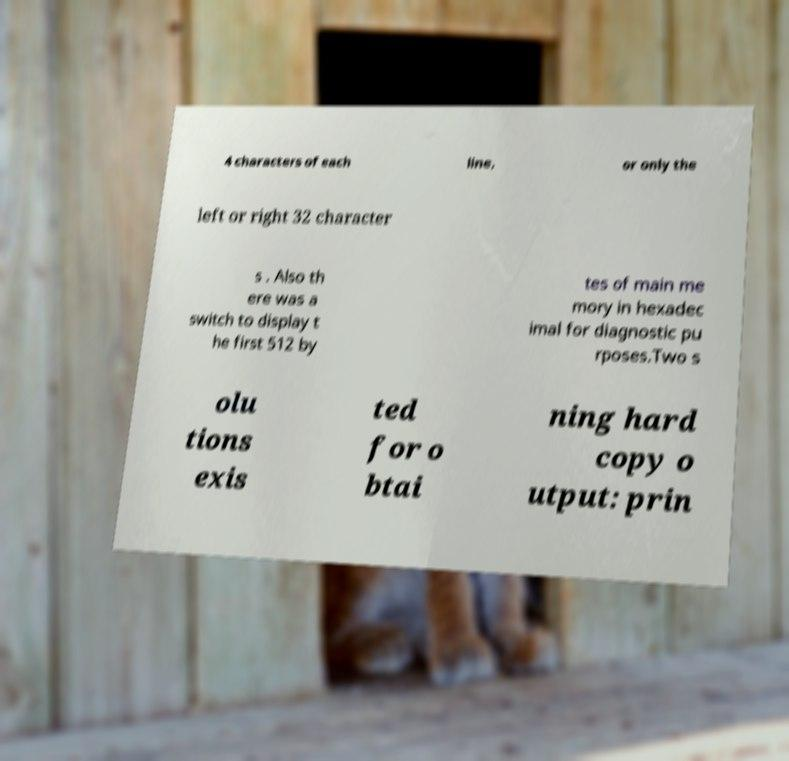Please read and relay the text visible in this image. What does it say? 4 characters of each line, or only the left or right 32 character s . Also th ere was a switch to display t he first 512 by tes of main me mory in hexadec imal for diagnostic pu rposes.Two s olu tions exis ted for o btai ning hard copy o utput: prin 